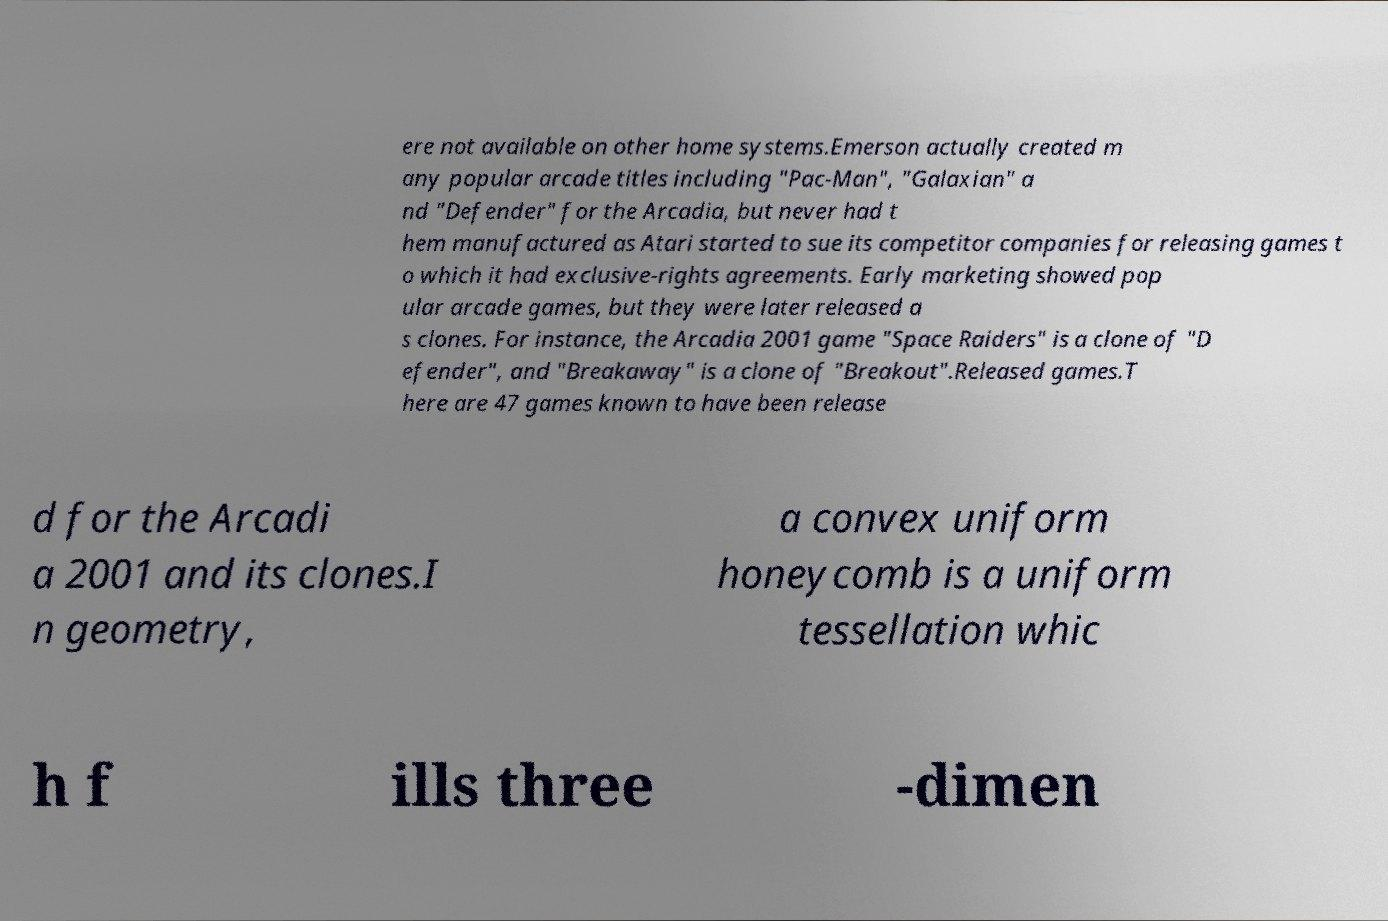Please read and relay the text visible in this image. What does it say? ere not available on other home systems.Emerson actually created m any popular arcade titles including "Pac-Man", "Galaxian" a nd "Defender" for the Arcadia, but never had t hem manufactured as Atari started to sue its competitor companies for releasing games t o which it had exclusive-rights agreements. Early marketing showed pop ular arcade games, but they were later released a s clones. For instance, the Arcadia 2001 game "Space Raiders" is a clone of "D efender", and "Breakaway" is a clone of "Breakout".Released games.T here are 47 games known to have been release d for the Arcadi a 2001 and its clones.I n geometry, a convex uniform honeycomb is a uniform tessellation whic h f ills three -dimen 